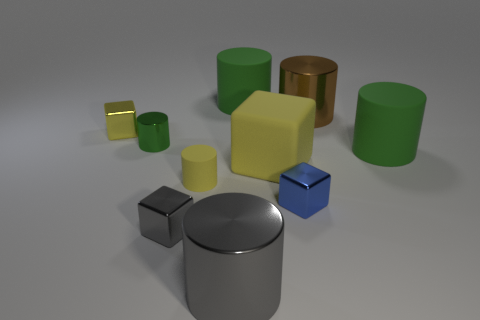Are there any big blocks that are to the left of the small block that is to the left of the gray block?
Your answer should be very brief. No. What number of large green rubber cylinders are there?
Offer a terse response. 2. There is a large object that is both to the left of the large brown cylinder and behind the small green shiny cylinder; what color is it?
Keep it short and to the point. Green. What size is the yellow object that is the same shape as the green shiny object?
Your response must be concise. Small. How many gray cubes are the same size as the blue object?
Provide a short and direct response. 1. What is the material of the big gray thing?
Offer a terse response. Metal. There is a rubber cube; are there any green matte objects on the right side of it?
Offer a terse response. Yes. There is a green object that is made of the same material as the large brown cylinder; what is its size?
Give a very brief answer. Small. How many large metal cylinders have the same color as the small matte thing?
Your response must be concise. 0. Is the number of gray shiny cylinders to the left of the tiny green object less than the number of objects left of the small blue shiny object?
Ensure brevity in your answer.  Yes. 